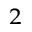Convert formula to latex. <formula><loc_0><loc_0><loc_500><loc_500>_ { 2 }</formula> 